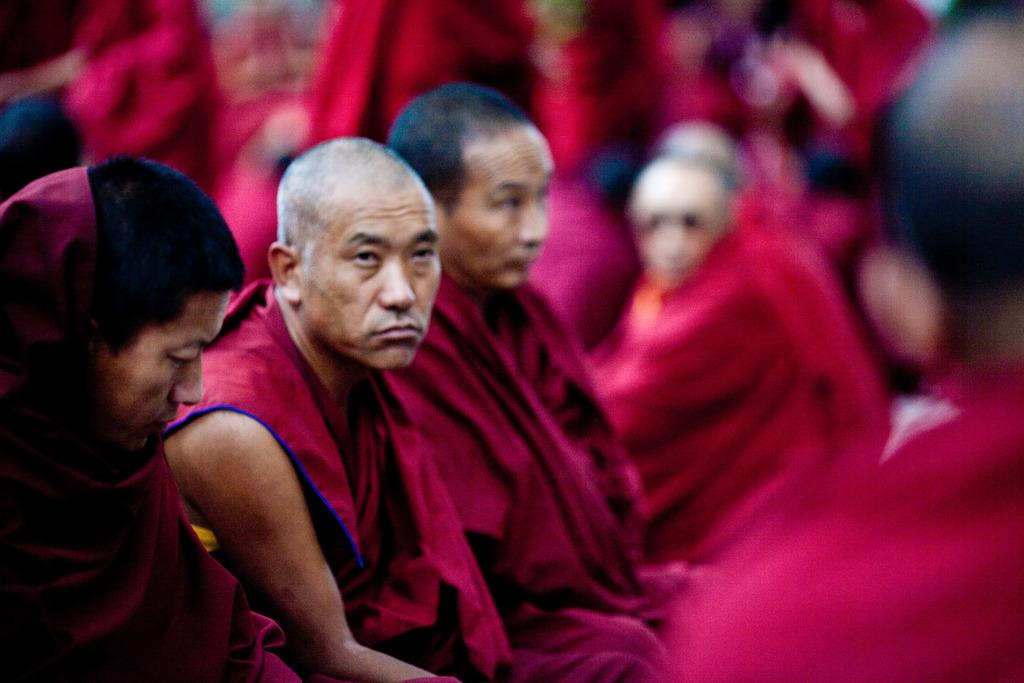What can be seen in the image in the image? There is a group of people in the image. What are the people wearing? The people are wearing red color dresses. Can you describe the background of the image? The background of the image is blurred. What type of news is being reported by the produce in the image? There is no produce or news reporting present in the image; it features a group of people wearing red color dresses with a blurred background. 